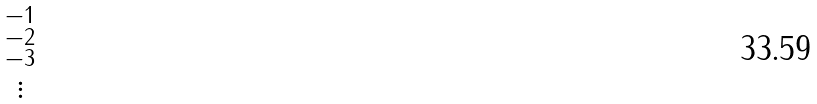Convert formula to latex. <formula><loc_0><loc_0><loc_500><loc_500>\begin{smallmatrix} - 1 \\ - 2 \\ - 3 \\ \vdots \end{smallmatrix}</formula> 